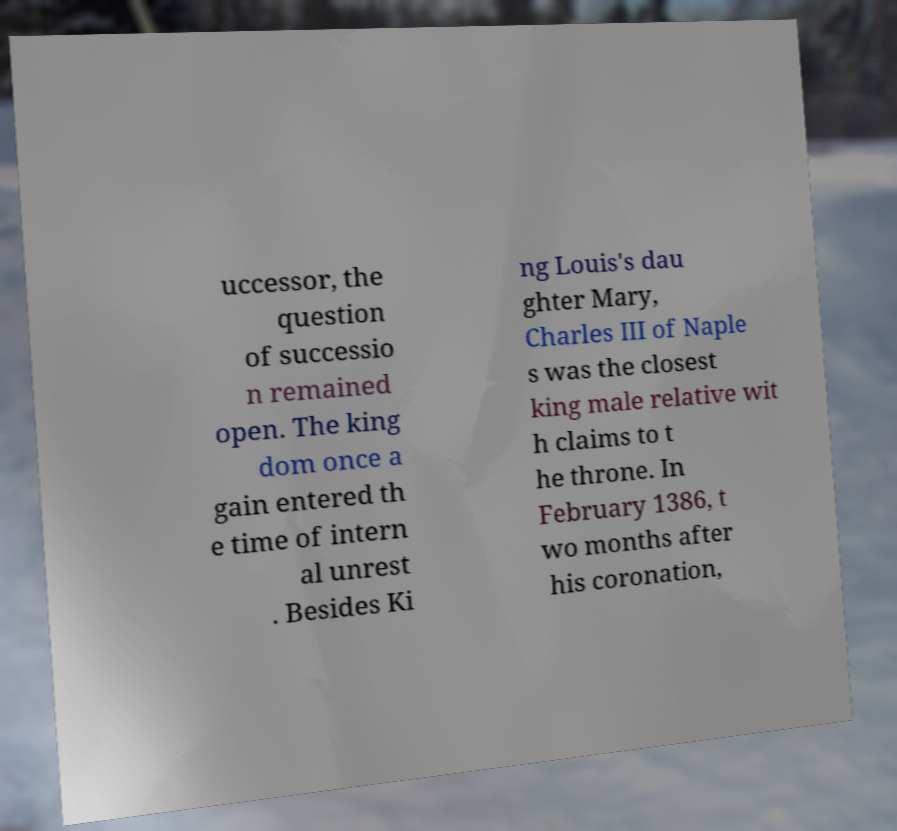What messages or text are displayed in this image? I need them in a readable, typed format. uccessor, the question of successio n remained open. The king dom once a gain entered th e time of intern al unrest . Besides Ki ng Louis's dau ghter Mary, Charles III of Naple s was the closest king male relative wit h claims to t he throne. In February 1386, t wo months after his coronation, 